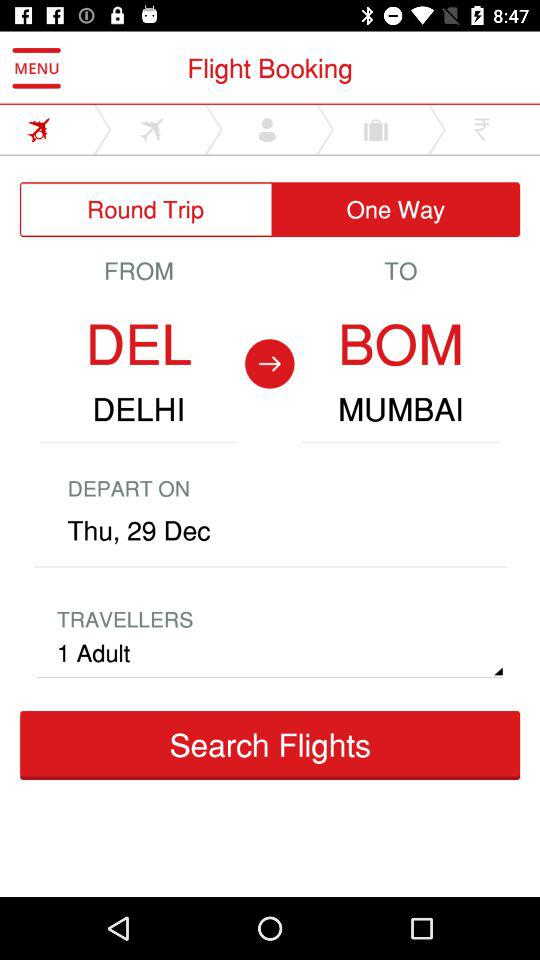What is the departure date?
Answer the question using a single word or phrase. Thu, 29 Dec 